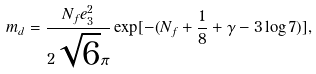<formula> <loc_0><loc_0><loc_500><loc_500>m _ { d } = \frac { N _ { f } e _ { 3 } ^ { 2 } } { 2 \sqrt { 6 } \pi } \exp [ - ( N _ { f } + \frac { 1 } { 8 } + \gamma - 3 \log 7 ) ] ,</formula> 